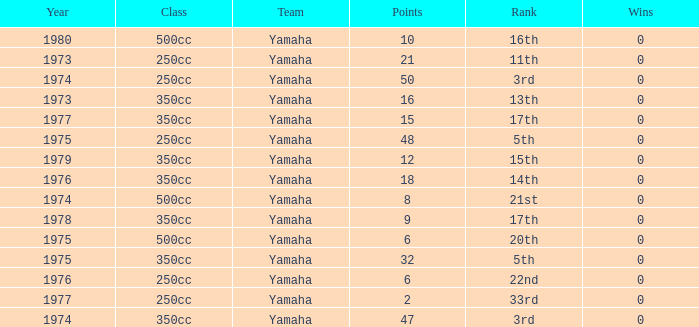Which wins possess a class of 500cc and a year less than 1975? 0.0. 